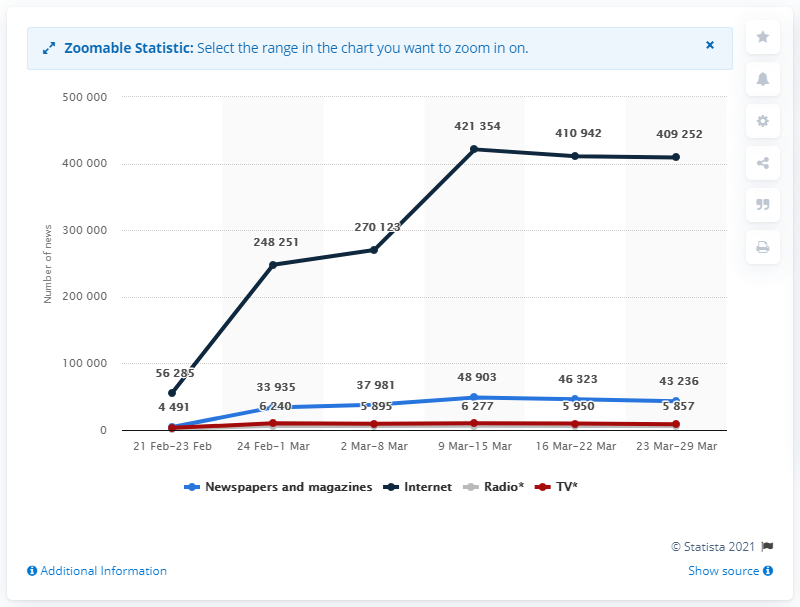Give some essential details in this illustration. During the period of March 9 to 15, there were a total of 421,354 news releases. 